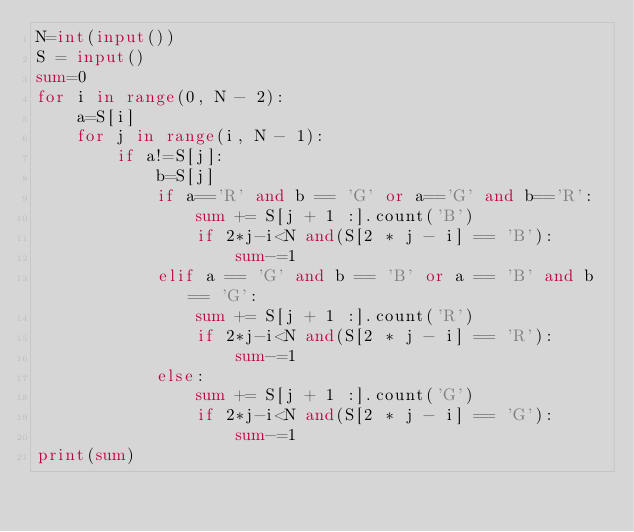Convert code to text. <code><loc_0><loc_0><loc_500><loc_500><_Python_>N=int(input())
S = input()
sum=0
for i in range(0, N - 2):
    a=S[i]
    for j in range(i, N - 1):
        if a!=S[j]:
            b=S[j]
            if a=='R' and b == 'G' or a=='G' and b=='R':
                sum += S[j + 1 :].count('B')
                if 2*j-i<N and(S[2 * j - i] == 'B'):
                    sum-=1
            elif a == 'G' and b == 'B' or a == 'B' and b == 'G':
                sum += S[j + 1 :].count('R')
                if 2*j-i<N and(S[2 * j - i] == 'R'):
                    sum-=1
            else:
                sum += S[j + 1 :].count('G')
                if 2*j-i<N and(S[2 * j - i] == 'G'):
                    sum-=1
print(sum)</code> 